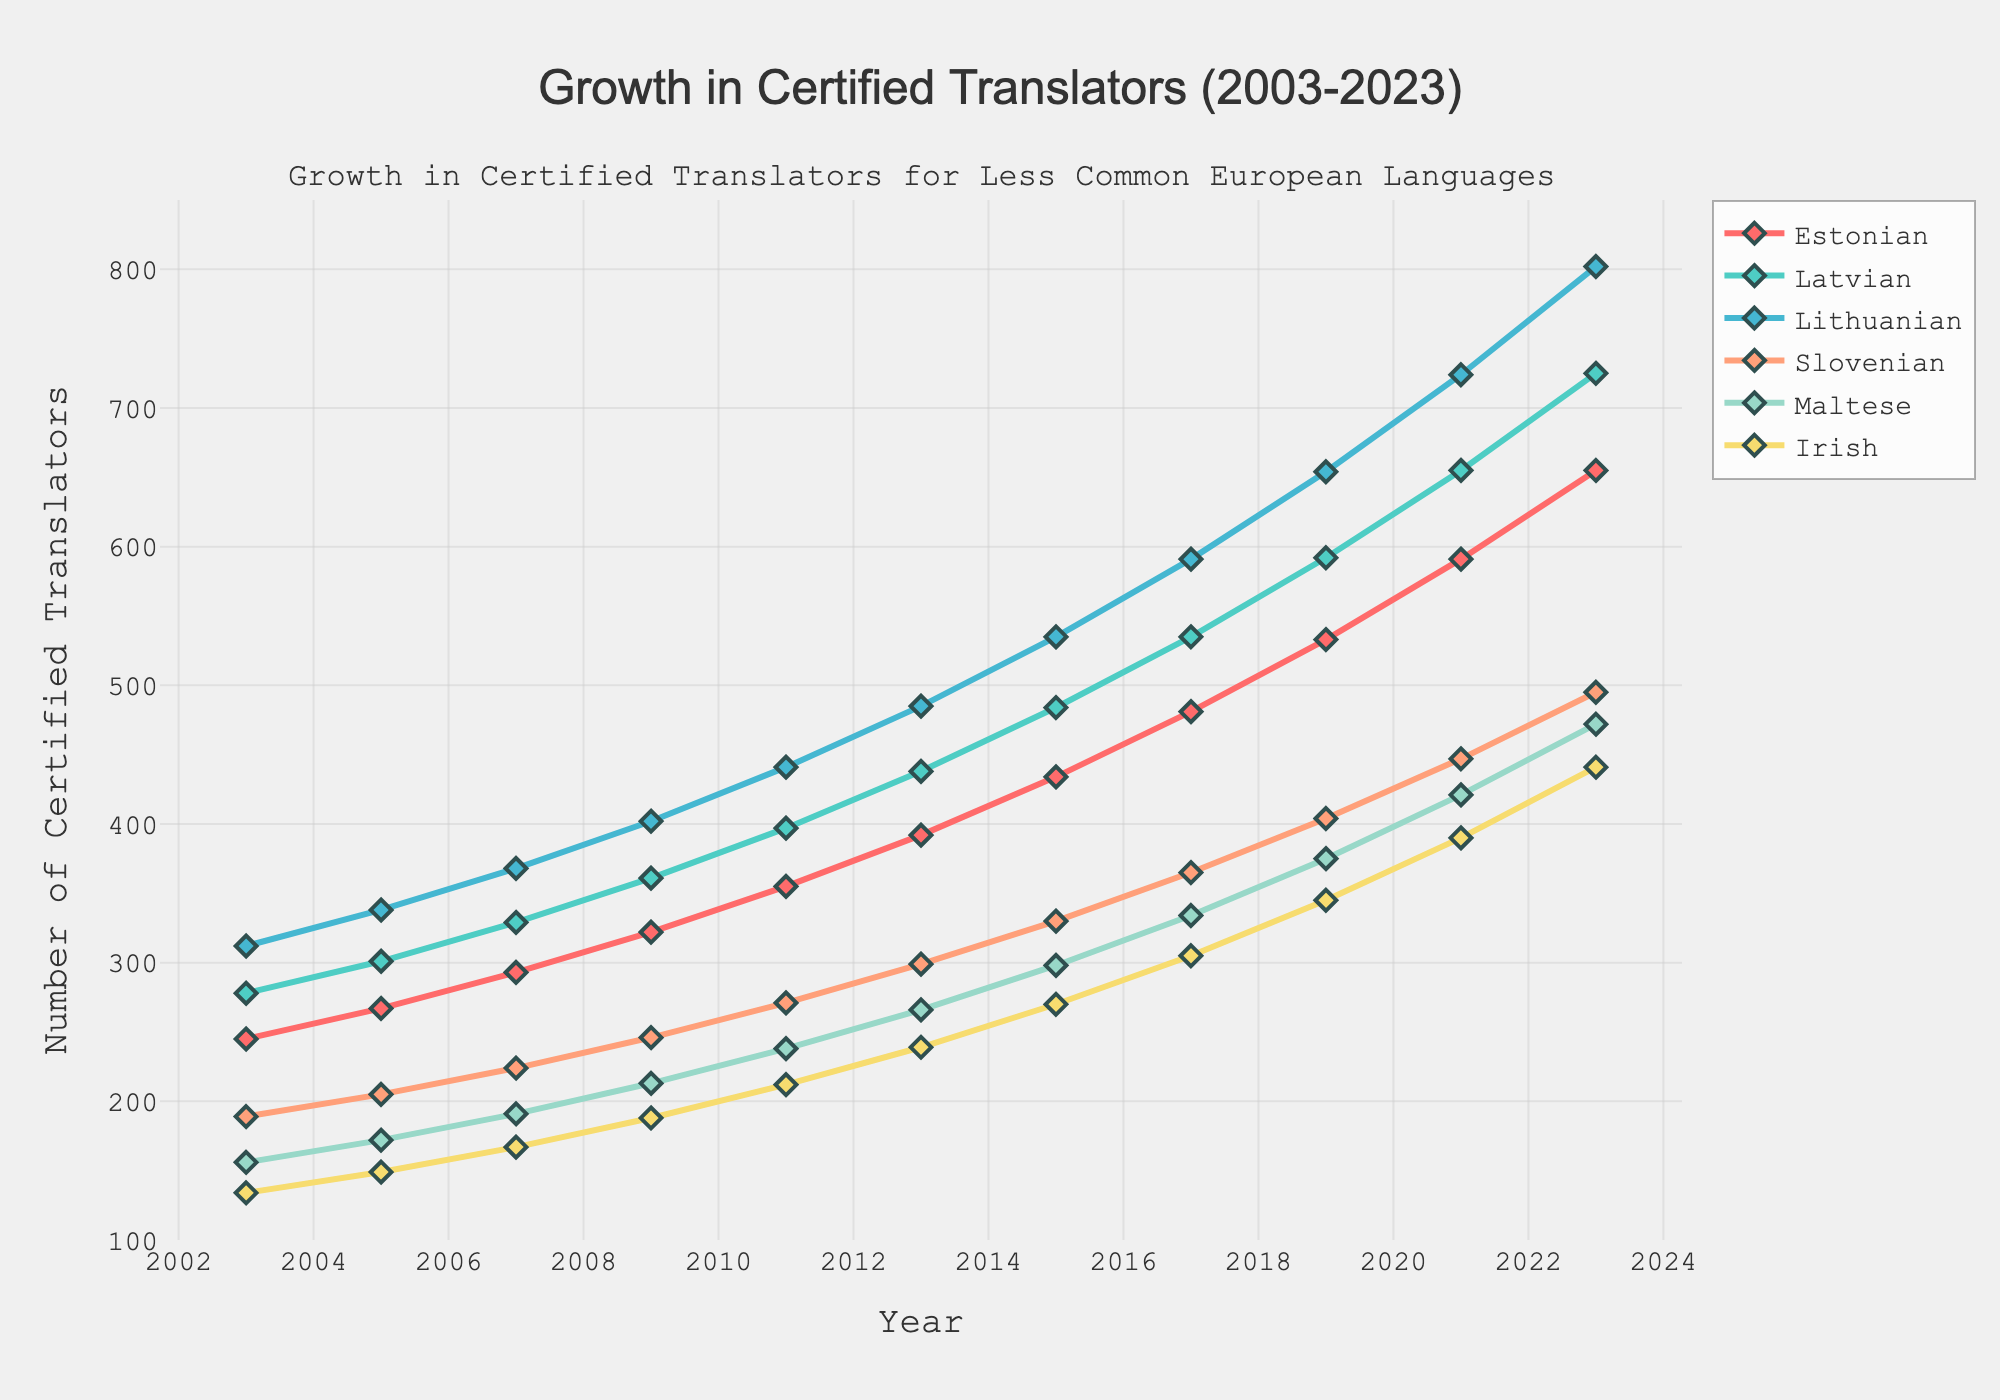Which language saw the greatest increase in certified translators from 2003 to 2023? First, find the number of certified translators for each language in 2023, then subtract the 2003 values. The increase for Estonian is 655 - 245 = 410, Latvian is 725 - 278 = 447, Lithuanian is 802 - 312 = 490, Slovenian is 495 - 189 = 306, Maltese is 472 - 156 = 316, Irish is 441 - 134 = 307. Lithuanian has the greatest increase.
Answer: Lithuanian Which year saw the highest number of certified Latvian translators? Compare the number of Latvian translators for each year provided in the data. The values steadily increase, reaching 725 in 2023, which is the highest number.
Answer: 2023 How many more Lithuanian translators were there in 2021 compared to 2015? Subtract the number of Lithuanian translators in 2015 from that in 2021: 724 - 535 = 189.
Answer: 189 Which language had the least number of certified translators in 2003, and what was that number? Compare the values for all languages in 2003: Estonian (245), Latvian (278), Lithuanian (312), Slovenian (189), Maltese (156), Irish (134). Irish has the least number with 134.
Answer: Irish, 134 By how much did the number of certified Estonian translators grow between 2013 and 2023? Subtract the number of Estonian translators in 2013 from the value in 2023: 655 - 392 = 263.
Answer: 263 Which year showed a significant increase in the number of certified Slovenian translators? Analyze the data for Slovenian translators and identify which year had a notably higher increase compared to others. From 2011 to 2013, the increase is from 271 to 299, which is 28, noticeably higher compared to other intervals.
Answer: 2013 What is the average number of certified Lithuanian translators over the 20-year period? Sum the number of Lithuanian translators for each year and then divide by the number of years: (312 + 338 + 368 + 402 + 441 + 485 + 535 + 591 + 654 + 724 + 802) / 11 ≈ 483.
Answer: 483 Which two languages had the most similar number of certified translators in 2023? Compare the 2023 values: Estonian (655), Latvian (725), Lithuanian (802), Slovenian (495), Maltese (472), Irish (441). Maltese (472) and Slovenian (495) are the closest.
Answer: Maltese and Slovenian In what year did all the languages reach at least 300 certified translators? Verify the year in which the number of certified translators for each language is 300 or more. In 2017, every language has at least 300: Estonian (481), Latvian (535), Lithuanian (591), Slovenian (365), Maltese (334), Irish (305).
Answer: 2017 